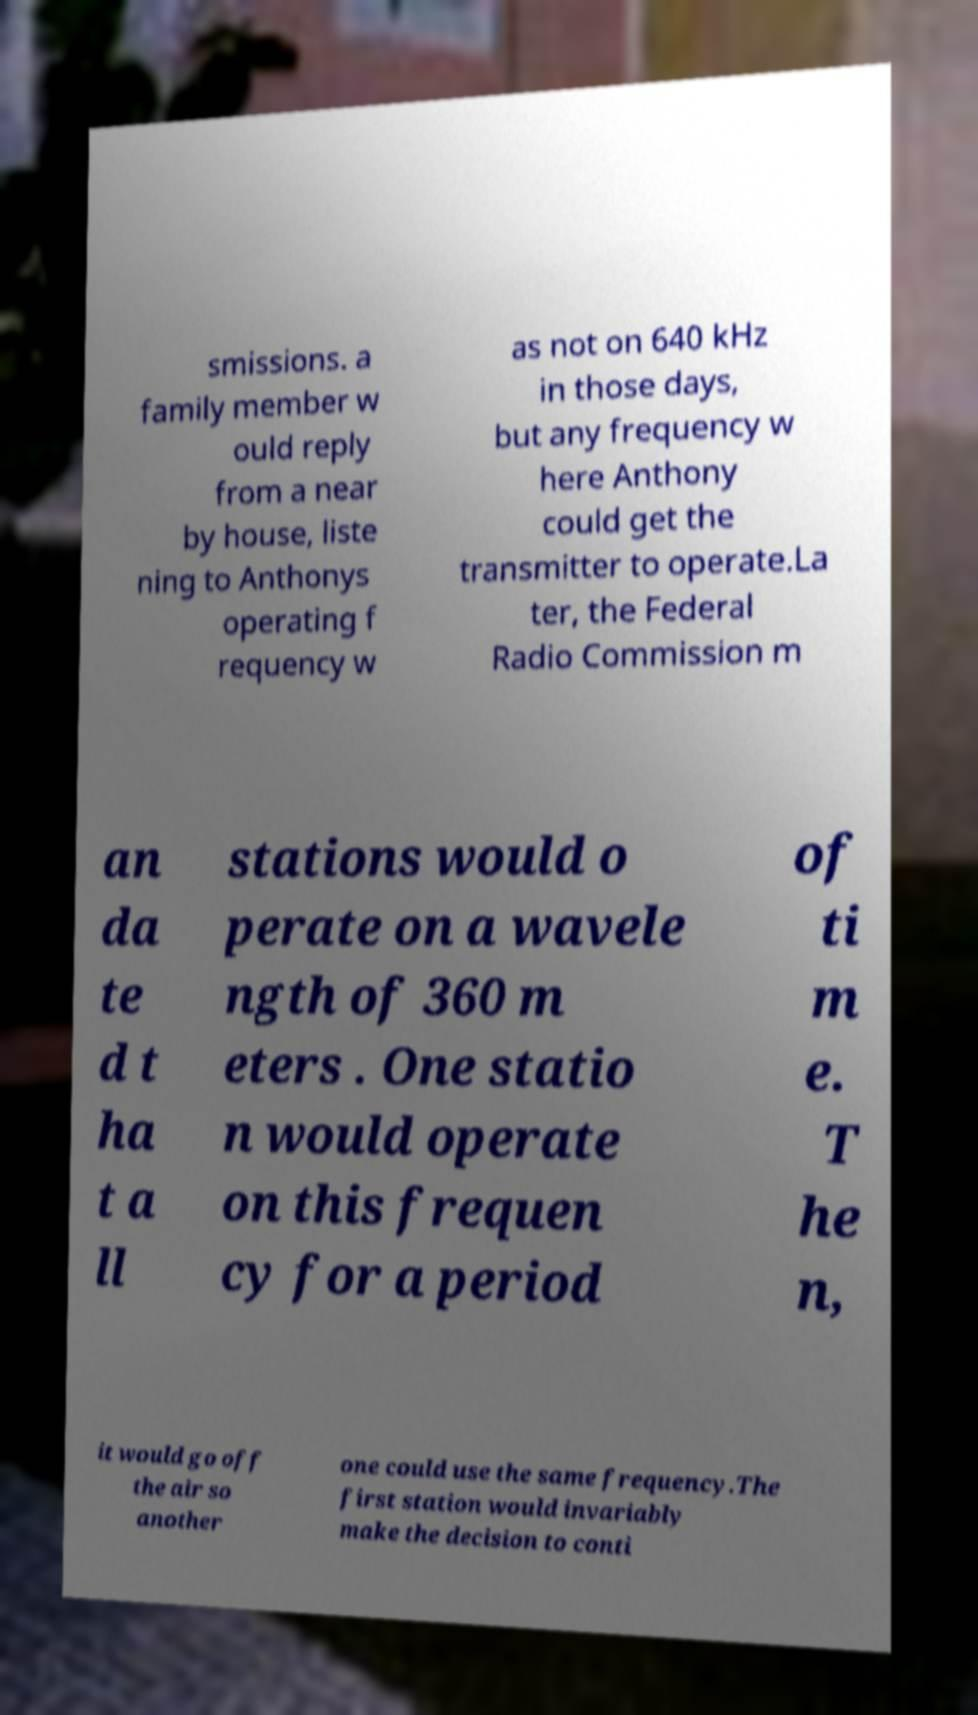For documentation purposes, I need the text within this image transcribed. Could you provide that? smissions. a family member w ould reply from a near by house, liste ning to Anthonys operating f requency w as not on 640 kHz in those days, but any frequency w here Anthony could get the transmitter to operate.La ter, the Federal Radio Commission m an da te d t ha t a ll stations would o perate on a wavele ngth of 360 m eters . One statio n would operate on this frequen cy for a period of ti m e. T he n, it would go off the air so another one could use the same frequency.The first station would invariably make the decision to conti 